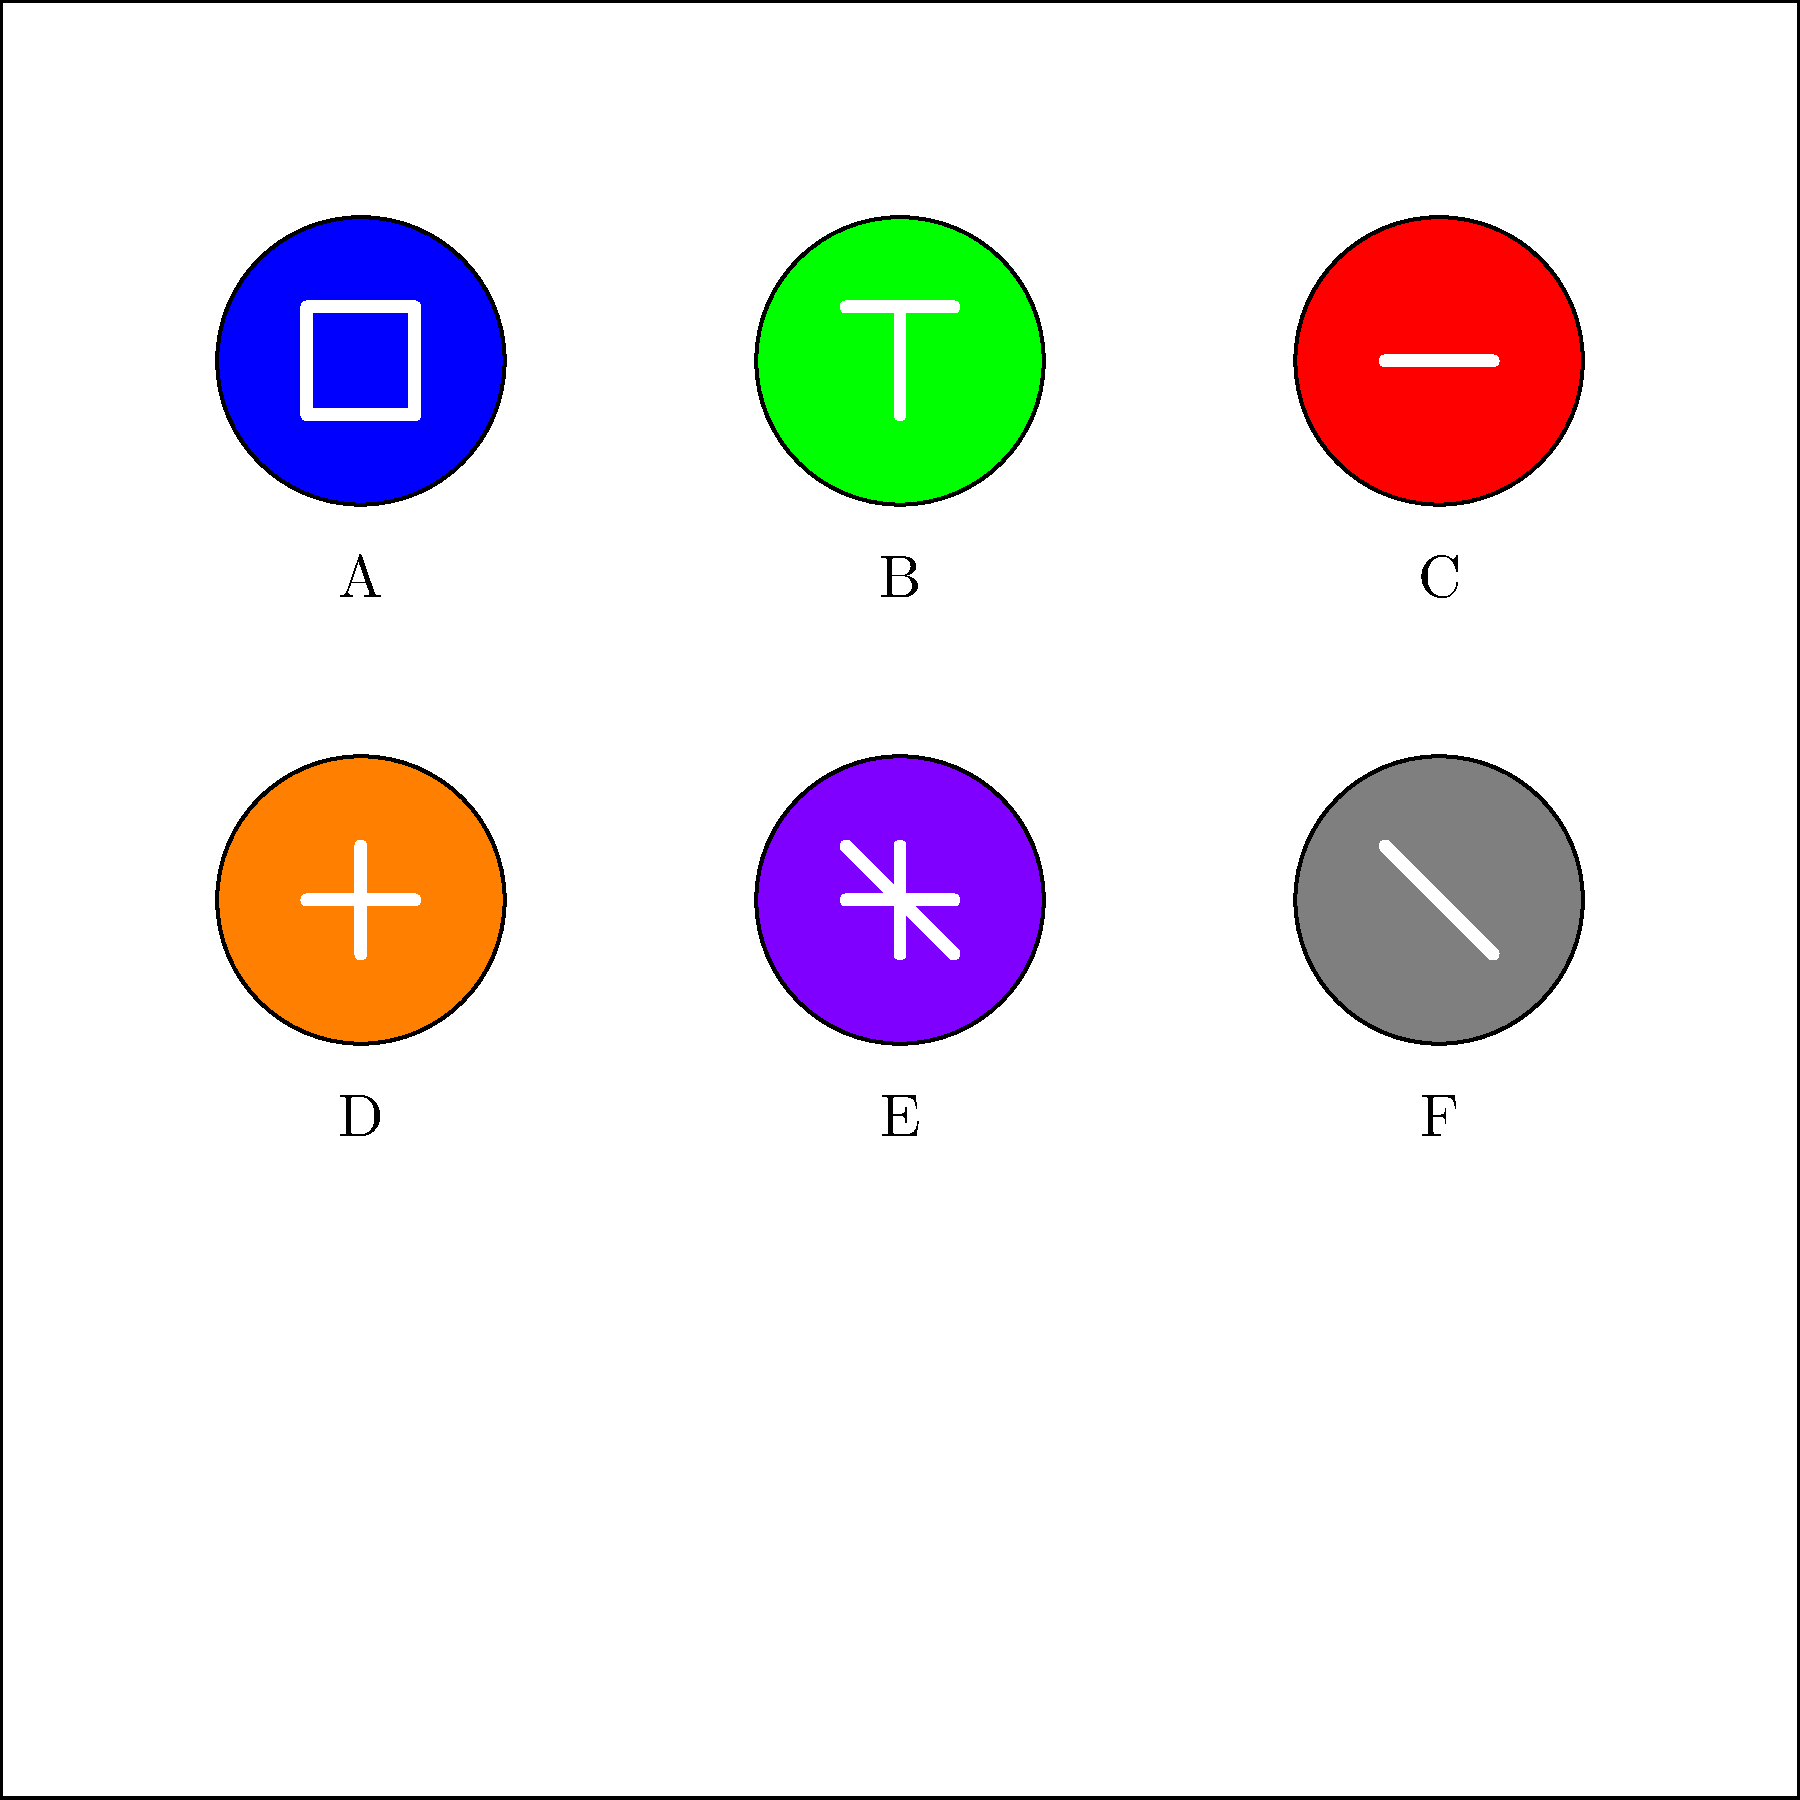Which of the icons shown above represents the "Friend Request" function on Facebook? To identify the "Friend Request" icon on Facebook, let's examine each icon:

1. Icon A (Blue): This shows a silhouette of a person, typically representing the user's profile or account settings.
2. Icon B (Green): This displays a plus sign, which is commonly used for adding or creating new content.
3. Icon C (Red): This shows a horizontal line, often used to represent notifications or alerts.
4. Icon D (Orange): This icon shows both a horizontal and vertical line forming a plus sign, which is the standard symbol for sending a friend request on Facebook.
5. Icon E (Purple): This icon shows an "X" shape, typically used for closing or removing items.
6. Icon F (Gray): This icon shows a diagonal line, often used to represent a back or return function.

Based on these descriptions, the icon that represents the "Friend Request" function on Facebook is Icon D, which shows a plus sign formed by intersecting horizontal and vertical lines.
Answer: D 